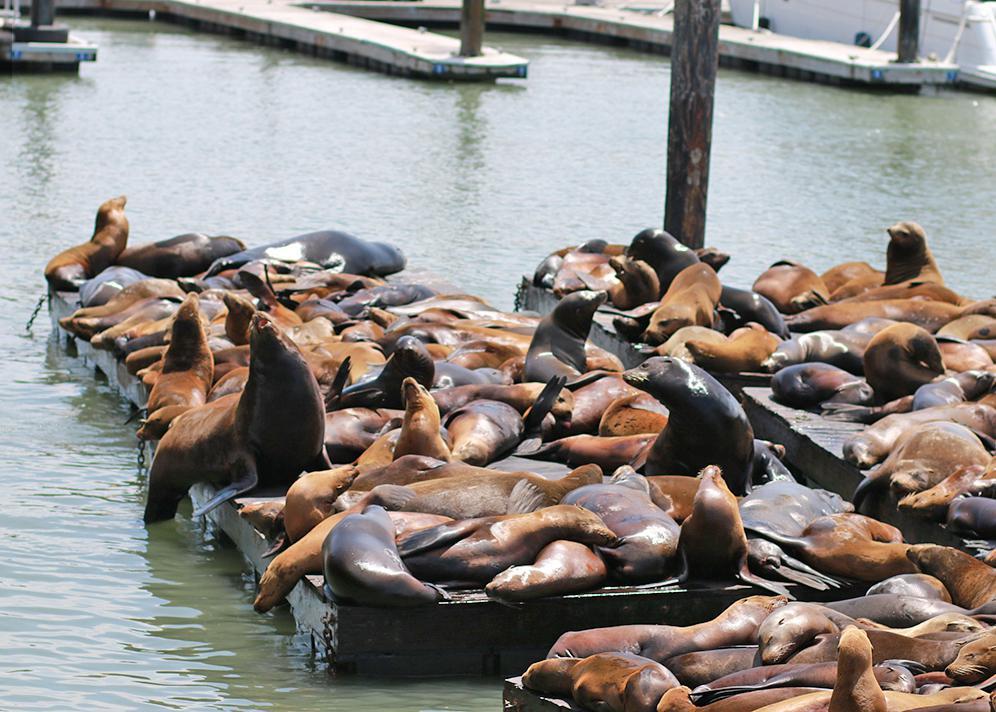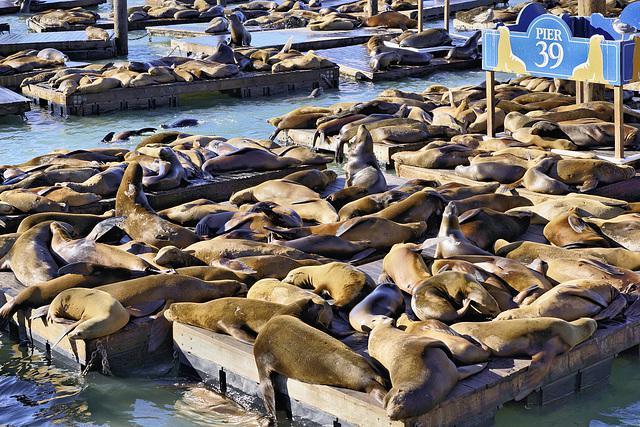The first image is the image on the left, the second image is the image on the right. Considering the images on both sides, is "The corners of floating platforms piled with reclining seals are visible in just one image." valid? Answer yes or no. No. The first image is the image on the left, the second image is the image on the right. Given the left and right images, does the statement "In at least one of the images, there are vertical wooden poles sticking up from the docks." hold true? Answer yes or no. Yes. 